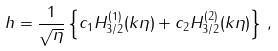Convert formula to latex. <formula><loc_0><loc_0><loc_500><loc_500>h = \frac { 1 } { \sqrt { \eta } } \left \{ c _ { 1 } H ^ { ( 1 ) } _ { 3 / 2 } ( k \eta ) + c _ { 2 } H ^ { ( 2 ) } _ { 3 / 2 } ( k \eta ) \right \} \, ,</formula> 